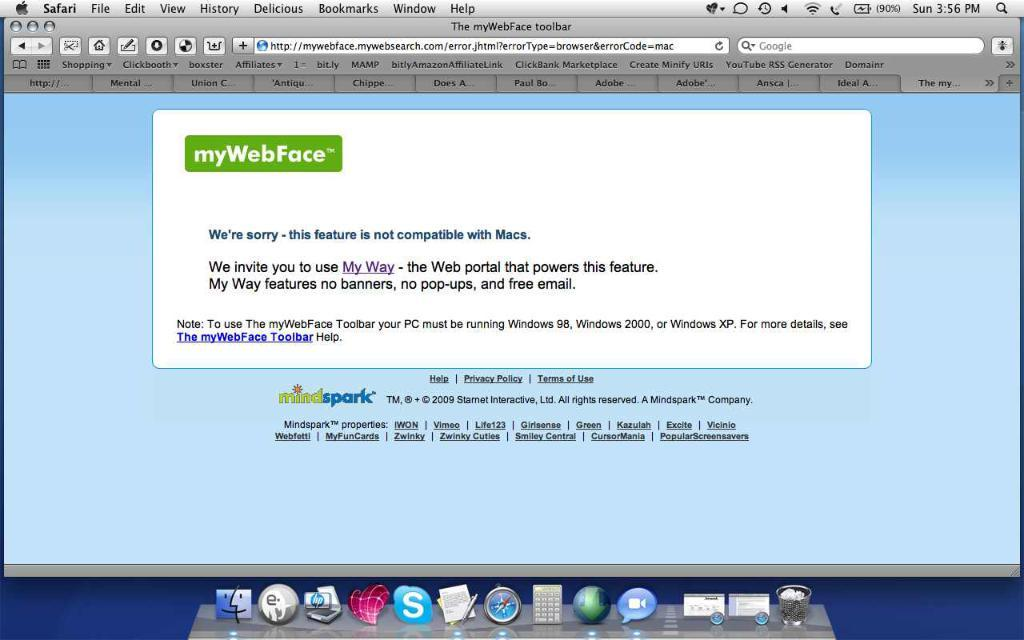<image>
Present a compact description of the photo's key features. An Apple computer monitor displays a website called myWebFace. 